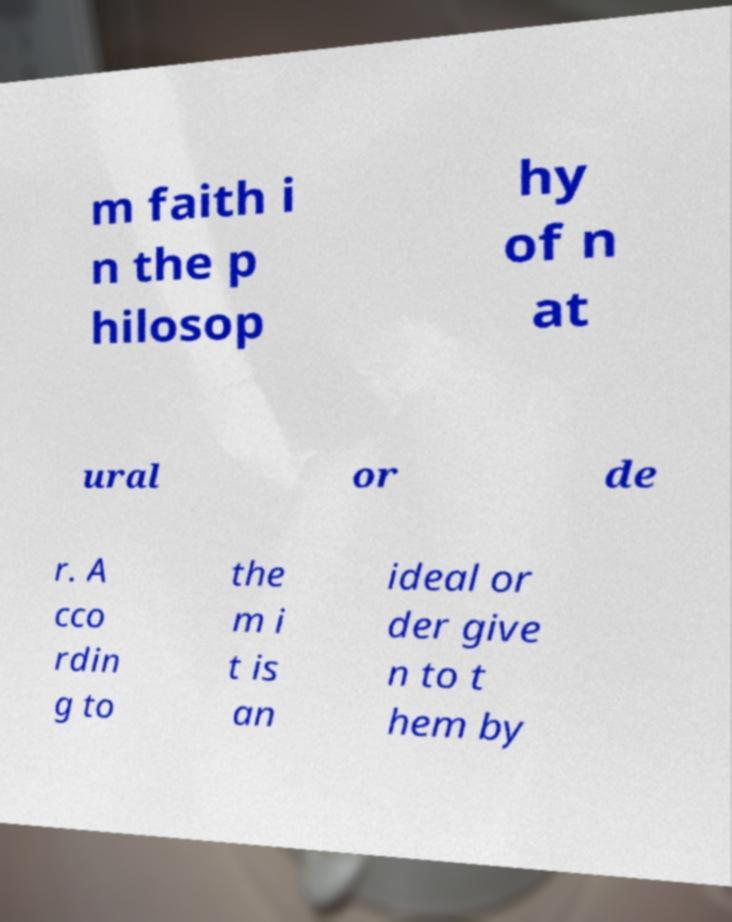Please read and relay the text visible in this image. What does it say? m faith i n the p hilosop hy of n at ural or de r. A cco rdin g to the m i t is an ideal or der give n to t hem by 